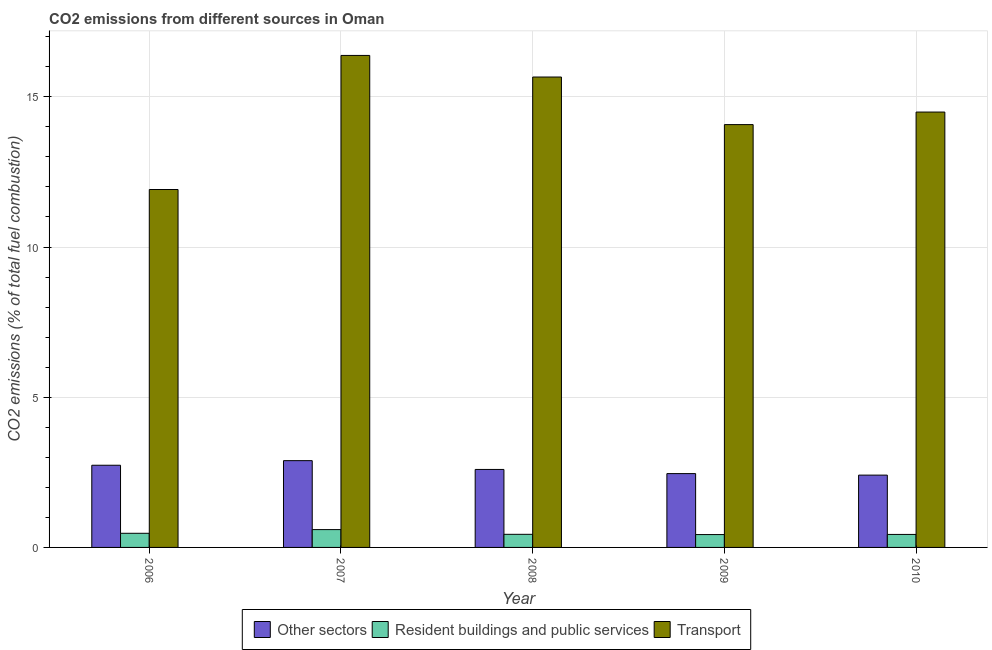How many bars are there on the 4th tick from the left?
Keep it short and to the point. 3. What is the label of the 5th group of bars from the left?
Your answer should be very brief. 2010. In how many cases, is the number of bars for a given year not equal to the number of legend labels?
Your answer should be compact. 0. What is the percentage of co2 emissions from resident buildings and public services in 2008?
Provide a short and direct response. 0.44. Across all years, what is the maximum percentage of co2 emissions from resident buildings and public services?
Ensure brevity in your answer.  0.59. Across all years, what is the minimum percentage of co2 emissions from transport?
Offer a terse response. 11.92. In which year was the percentage of co2 emissions from resident buildings and public services maximum?
Offer a terse response. 2007. What is the total percentage of co2 emissions from other sectors in the graph?
Offer a terse response. 13.09. What is the difference between the percentage of co2 emissions from transport in 2009 and that in 2010?
Keep it short and to the point. -0.42. What is the difference between the percentage of co2 emissions from resident buildings and public services in 2010 and the percentage of co2 emissions from transport in 2006?
Your answer should be compact. -0.04. What is the average percentage of co2 emissions from transport per year?
Ensure brevity in your answer.  14.5. In the year 2007, what is the difference between the percentage of co2 emissions from resident buildings and public services and percentage of co2 emissions from transport?
Provide a succinct answer. 0. In how many years, is the percentage of co2 emissions from resident buildings and public services greater than 12 %?
Provide a short and direct response. 0. What is the ratio of the percentage of co2 emissions from resident buildings and public services in 2007 to that in 2008?
Your response must be concise. 1.36. What is the difference between the highest and the second highest percentage of co2 emissions from other sectors?
Your answer should be very brief. 0.15. What is the difference between the highest and the lowest percentage of co2 emissions from other sectors?
Make the answer very short. 0.48. Is the sum of the percentage of co2 emissions from other sectors in 2006 and 2007 greater than the maximum percentage of co2 emissions from resident buildings and public services across all years?
Offer a very short reply. Yes. What does the 2nd bar from the left in 2007 represents?
Your answer should be compact. Resident buildings and public services. What does the 1st bar from the right in 2007 represents?
Your answer should be very brief. Transport. Is it the case that in every year, the sum of the percentage of co2 emissions from other sectors and percentage of co2 emissions from resident buildings and public services is greater than the percentage of co2 emissions from transport?
Your answer should be very brief. No. How many bars are there?
Your response must be concise. 15. Are the values on the major ticks of Y-axis written in scientific E-notation?
Provide a short and direct response. No. Does the graph contain any zero values?
Provide a succinct answer. No. Does the graph contain grids?
Make the answer very short. Yes. Where does the legend appear in the graph?
Your answer should be compact. Bottom center. How many legend labels are there?
Ensure brevity in your answer.  3. What is the title of the graph?
Keep it short and to the point. CO2 emissions from different sources in Oman. What is the label or title of the X-axis?
Provide a succinct answer. Year. What is the label or title of the Y-axis?
Give a very brief answer. CO2 emissions (% of total fuel combustion). What is the CO2 emissions (% of total fuel combustion) in Other sectors in 2006?
Keep it short and to the point. 2.74. What is the CO2 emissions (% of total fuel combustion) of Resident buildings and public services in 2006?
Your answer should be very brief. 0.47. What is the CO2 emissions (% of total fuel combustion) in Transport in 2006?
Make the answer very short. 11.92. What is the CO2 emissions (% of total fuel combustion) in Other sectors in 2007?
Offer a terse response. 2.89. What is the CO2 emissions (% of total fuel combustion) in Resident buildings and public services in 2007?
Your answer should be very brief. 0.59. What is the CO2 emissions (% of total fuel combustion) of Transport in 2007?
Ensure brevity in your answer.  16.38. What is the CO2 emissions (% of total fuel combustion) in Other sectors in 2008?
Keep it short and to the point. 2.6. What is the CO2 emissions (% of total fuel combustion) in Resident buildings and public services in 2008?
Offer a terse response. 0.44. What is the CO2 emissions (% of total fuel combustion) in Transport in 2008?
Make the answer very short. 15.66. What is the CO2 emissions (% of total fuel combustion) of Other sectors in 2009?
Make the answer very short. 2.46. What is the CO2 emissions (% of total fuel combustion) in Resident buildings and public services in 2009?
Ensure brevity in your answer.  0.43. What is the CO2 emissions (% of total fuel combustion) of Transport in 2009?
Your response must be concise. 14.08. What is the CO2 emissions (% of total fuel combustion) in Other sectors in 2010?
Make the answer very short. 2.41. What is the CO2 emissions (% of total fuel combustion) in Resident buildings and public services in 2010?
Provide a short and direct response. 0.43. What is the CO2 emissions (% of total fuel combustion) of Transport in 2010?
Your answer should be very brief. 14.49. Across all years, what is the maximum CO2 emissions (% of total fuel combustion) in Other sectors?
Your answer should be very brief. 2.89. Across all years, what is the maximum CO2 emissions (% of total fuel combustion) in Resident buildings and public services?
Offer a very short reply. 0.59. Across all years, what is the maximum CO2 emissions (% of total fuel combustion) of Transport?
Your response must be concise. 16.38. Across all years, what is the minimum CO2 emissions (% of total fuel combustion) of Other sectors?
Offer a very short reply. 2.41. Across all years, what is the minimum CO2 emissions (% of total fuel combustion) of Resident buildings and public services?
Offer a terse response. 0.43. Across all years, what is the minimum CO2 emissions (% of total fuel combustion) in Transport?
Your response must be concise. 11.92. What is the total CO2 emissions (% of total fuel combustion) of Other sectors in the graph?
Your answer should be very brief. 13.09. What is the total CO2 emissions (% of total fuel combustion) in Resident buildings and public services in the graph?
Give a very brief answer. 2.36. What is the total CO2 emissions (% of total fuel combustion) in Transport in the graph?
Your answer should be compact. 72.52. What is the difference between the CO2 emissions (% of total fuel combustion) in Other sectors in 2006 and that in 2007?
Provide a succinct answer. -0.15. What is the difference between the CO2 emissions (% of total fuel combustion) of Resident buildings and public services in 2006 and that in 2007?
Ensure brevity in your answer.  -0.12. What is the difference between the CO2 emissions (% of total fuel combustion) of Transport in 2006 and that in 2007?
Provide a succinct answer. -4.46. What is the difference between the CO2 emissions (% of total fuel combustion) in Other sectors in 2006 and that in 2008?
Offer a very short reply. 0.14. What is the difference between the CO2 emissions (% of total fuel combustion) of Resident buildings and public services in 2006 and that in 2008?
Make the answer very short. 0.03. What is the difference between the CO2 emissions (% of total fuel combustion) of Transport in 2006 and that in 2008?
Give a very brief answer. -3.74. What is the difference between the CO2 emissions (% of total fuel combustion) in Other sectors in 2006 and that in 2009?
Provide a short and direct response. 0.28. What is the difference between the CO2 emissions (% of total fuel combustion) in Resident buildings and public services in 2006 and that in 2009?
Give a very brief answer. 0.04. What is the difference between the CO2 emissions (% of total fuel combustion) in Transport in 2006 and that in 2009?
Keep it short and to the point. -2.16. What is the difference between the CO2 emissions (% of total fuel combustion) of Other sectors in 2006 and that in 2010?
Provide a short and direct response. 0.33. What is the difference between the CO2 emissions (% of total fuel combustion) of Resident buildings and public services in 2006 and that in 2010?
Provide a succinct answer. 0.04. What is the difference between the CO2 emissions (% of total fuel combustion) in Transport in 2006 and that in 2010?
Keep it short and to the point. -2.58. What is the difference between the CO2 emissions (% of total fuel combustion) of Other sectors in 2007 and that in 2008?
Give a very brief answer. 0.29. What is the difference between the CO2 emissions (% of total fuel combustion) of Resident buildings and public services in 2007 and that in 2008?
Make the answer very short. 0.16. What is the difference between the CO2 emissions (% of total fuel combustion) in Transport in 2007 and that in 2008?
Your answer should be compact. 0.72. What is the difference between the CO2 emissions (% of total fuel combustion) in Other sectors in 2007 and that in 2009?
Provide a succinct answer. 0.43. What is the difference between the CO2 emissions (% of total fuel combustion) in Resident buildings and public services in 2007 and that in 2009?
Offer a terse response. 0.17. What is the difference between the CO2 emissions (% of total fuel combustion) of Transport in 2007 and that in 2009?
Your answer should be compact. 2.3. What is the difference between the CO2 emissions (% of total fuel combustion) in Other sectors in 2007 and that in 2010?
Your response must be concise. 0.48. What is the difference between the CO2 emissions (% of total fuel combustion) in Resident buildings and public services in 2007 and that in 2010?
Make the answer very short. 0.16. What is the difference between the CO2 emissions (% of total fuel combustion) in Transport in 2007 and that in 2010?
Your answer should be compact. 1.89. What is the difference between the CO2 emissions (% of total fuel combustion) in Other sectors in 2008 and that in 2009?
Make the answer very short. 0.14. What is the difference between the CO2 emissions (% of total fuel combustion) in Resident buildings and public services in 2008 and that in 2009?
Your answer should be very brief. 0.01. What is the difference between the CO2 emissions (% of total fuel combustion) of Transport in 2008 and that in 2009?
Ensure brevity in your answer.  1.58. What is the difference between the CO2 emissions (% of total fuel combustion) of Other sectors in 2008 and that in 2010?
Your answer should be compact. 0.19. What is the difference between the CO2 emissions (% of total fuel combustion) in Resident buildings and public services in 2008 and that in 2010?
Provide a succinct answer. 0. What is the difference between the CO2 emissions (% of total fuel combustion) of Transport in 2008 and that in 2010?
Provide a succinct answer. 1.17. What is the difference between the CO2 emissions (% of total fuel combustion) of Other sectors in 2009 and that in 2010?
Your answer should be very brief. 0.05. What is the difference between the CO2 emissions (% of total fuel combustion) of Resident buildings and public services in 2009 and that in 2010?
Offer a very short reply. -0. What is the difference between the CO2 emissions (% of total fuel combustion) in Transport in 2009 and that in 2010?
Your answer should be compact. -0.42. What is the difference between the CO2 emissions (% of total fuel combustion) of Other sectors in 2006 and the CO2 emissions (% of total fuel combustion) of Resident buildings and public services in 2007?
Ensure brevity in your answer.  2.14. What is the difference between the CO2 emissions (% of total fuel combustion) in Other sectors in 2006 and the CO2 emissions (% of total fuel combustion) in Transport in 2007?
Your answer should be compact. -13.64. What is the difference between the CO2 emissions (% of total fuel combustion) in Resident buildings and public services in 2006 and the CO2 emissions (% of total fuel combustion) in Transport in 2007?
Your answer should be very brief. -15.91. What is the difference between the CO2 emissions (% of total fuel combustion) in Other sectors in 2006 and the CO2 emissions (% of total fuel combustion) in Transport in 2008?
Ensure brevity in your answer.  -12.92. What is the difference between the CO2 emissions (% of total fuel combustion) in Resident buildings and public services in 2006 and the CO2 emissions (% of total fuel combustion) in Transport in 2008?
Make the answer very short. -15.19. What is the difference between the CO2 emissions (% of total fuel combustion) in Other sectors in 2006 and the CO2 emissions (% of total fuel combustion) in Resident buildings and public services in 2009?
Provide a succinct answer. 2.31. What is the difference between the CO2 emissions (% of total fuel combustion) in Other sectors in 2006 and the CO2 emissions (% of total fuel combustion) in Transport in 2009?
Your response must be concise. -11.34. What is the difference between the CO2 emissions (% of total fuel combustion) of Resident buildings and public services in 2006 and the CO2 emissions (% of total fuel combustion) of Transport in 2009?
Provide a succinct answer. -13.6. What is the difference between the CO2 emissions (% of total fuel combustion) of Other sectors in 2006 and the CO2 emissions (% of total fuel combustion) of Resident buildings and public services in 2010?
Your response must be concise. 2.3. What is the difference between the CO2 emissions (% of total fuel combustion) in Other sectors in 2006 and the CO2 emissions (% of total fuel combustion) in Transport in 2010?
Make the answer very short. -11.76. What is the difference between the CO2 emissions (% of total fuel combustion) in Resident buildings and public services in 2006 and the CO2 emissions (% of total fuel combustion) in Transport in 2010?
Make the answer very short. -14.02. What is the difference between the CO2 emissions (% of total fuel combustion) in Other sectors in 2007 and the CO2 emissions (% of total fuel combustion) in Resident buildings and public services in 2008?
Keep it short and to the point. 2.45. What is the difference between the CO2 emissions (% of total fuel combustion) of Other sectors in 2007 and the CO2 emissions (% of total fuel combustion) of Transport in 2008?
Your answer should be compact. -12.77. What is the difference between the CO2 emissions (% of total fuel combustion) of Resident buildings and public services in 2007 and the CO2 emissions (% of total fuel combustion) of Transport in 2008?
Your answer should be compact. -15.07. What is the difference between the CO2 emissions (% of total fuel combustion) in Other sectors in 2007 and the CO2 emissions (% of total fuel combustion) in Resident buildings and public services in 2009?
Provide a short and direct response. 2.46. What is the difference between the CO2 emissions (% of total fuel combustion) of Other sectors in 2007 and the CO2 emissions (% of total fuel combustion) of Transport in 2009?
Give a very brief answer. -11.19. What is the difference between the CO2 emissions (% of total fuel combustion) of Resident buildings and public services in 2007 and the CO2 emissions (% of total fuel combustion) of Transport in 2009?
Provide a short and direct response. -13.48. What is the difference between the CO2 emissions (% of total fuel combustion) in Other sectors in 2007 and the CO2 emissions (% of total fuel combustion) in Resident buildings and public services in 2010?
Make the answer very short. 2.46. What is the difference between the CO2 emissions (% of total fuel combustion) of Other sectors in 2007 and the CO2 emissions (% of total fuel combustion) of Transport in 2010?
Your response must be concise. -11.6. What is the difference between the CO2 emissions (% of total fuel combustion) in Resident buildings and public services in 2007 and the CO2 emissions (% of total fuel combustion) in Transport in 2010?
Give a very brief answer. -13.9. What is the difference between the CO2 emissions (% of total fuel combustion) of Other sectors in 2008 and the CO2 emissions (% of total fuel combustion) of Resident buildings and public services in 2009?
Offer a very short reply. 2.17. What is the difference between the CO2 emissions (% of total fuel combustion) in Other sectors in 2008 and the CO2 emissions (% of total fuel combustion) in Transport in 2009?
Offer a very short reply. -11.48. What is the difference between the CO2 emissions (% of total fuel combustion) of Resident buildings and public services in 2008 and the CO2 emissions (% of total fuel combustion) of Transport in 2009?
Make the answer very short. -13.64. What is the difference between the CO2 emissions (% of total fuel combustion) of Other sectors in 2008 and the CO2 emissions (% of total fuel combustion) of Resident buildings and public services in 2010?
Offer a terse response. 2.16. What is the difference between the CO2 emissions (% of total fuel combustion) in Other sectors in 2008 and the CO2 emissions (% of total fuel combustion) in Transport in 2010?
Your answer should be very brief. -11.9. What is the difference between the CO2 emissions (% of total fuel combustion) of Resident buildings and public services in 2008 and the CO2 emissions (% of total fuel combustion) of Transport in 2010?
Offer a very short reply. -14.06. What is the difference between the CO2 emissions (% of total fuel combustion) in Other sectors in 2009 and the CO2 emissions (% of total fuel combustion) in Resident buildings and public services in 2010?
Offer a very short reply. 2.02. What is the difference between the CO2 emissions (% of total fuel combustion) of Other sectors in 2009 and the CO2 emissions (% of total fuel combustion) of Transport in 2010?
Your answer should be very brief. -12.04. What is the difference between the CO2 emissions (% of total fuel combustion) in Resident buildings and public services in 2009 and the CO2 emissions (% of total fuel combustion) in Transport in 2010?
Your answer should be compact. -14.07. What is the average CO2 emissions (% of total fuel combustion) of Other sectors per year?
Your answer should be compact. 2.62. What is the average CO2 emissions (% of total fuel combustion) of Resident buildings and public services per year?
Make the answer very short. 0.47. What is the average CO2 emissions (% of total fuel combustion) in Transport per year?
Ensure brevity in your answer.  14.5. In the year 2006, what is the difference between the CO2 emissions (% of total fuel combustion) of Other sectors and CO2 emissions (% of total fuel combustion) of Resident buildings and public services?
Offer a very short reply. 2.27. In the year 2006, what is the difference between the CO2 emissions (% of total fuel combustion) in Other sectors and CO2 emissions (% of total fuel combustion) in Transport?
Your answer should be very brief. -9.18. In the year 2006, what is the difference between the CO2 emissions (% of total fuel combustion) of Resident buildings and public services and CO2 emissions (% of total fuel combustion) of Transport?
Your response must be concise. -11.44. In the year 2007, what is the difference between the CO2 emissions (% of total fuel combustion) in Other sectors and CO2 emissions (% of total fuel combustion) in Resident buildings and public services?
Offer a terse response. 2.3. In the year 2007, what is the difference between the CO2 emissions (% of total fuel combustion) in Other sectors and CO2 emissions (% of total fuel combustion) in Transport?
Offer a very short reply. -13.49. In the year 2007, what is the difference between the CO2 emissions (% of total fuel combustion) in Resident buildings and public services and CO2 emissions (% of total fuel combustion) in Transport?
Provide a succinct answer. -15.79. In the year 2008, what is the difference between the CO2 emissions (% of total fuel combustion) in Other sectors and CO2 emissions (% of total fuel combustion) in Resident buildings and public services?
Offer a terse response. 2.16. In the year 2008, what is the difference between the CO2 emissions (% of total fuel combustion) in Other sectors and CO2 emissions (% of total fuel combustion) in Transport?
Make the answer very short. -13.06. In the year 2008, what is the difference between the CO2 emissions (% of total fuel combustion) of Resident buildings and public services and CO2 emissions (% of total fuel combustion) of Transport?
Your answer should be very brief. -15.22. In the year 2009, what is the difference between the CO2 emissions (% of total fuel combustion) in Other sectors and CO2 emissions (% of total fuel combustion) in Resident buildings and public services?
Keep it short and to the point. 2.03. In the year 2009, what is the difference between the CO2 emissions (% of total fuel combustion) in Other sectors and CO2 emissions (% of total fuel combustion) in Transport?
Give a very brief answer. -11.62. In the year 2009, what is the difference between the CO2 emissions (% of total fuel combustion) of Resident buildings and public services and CO2 emissions (% of total fuel combustion) of Transport?
Your response must be concise. -13.65. In the year 2010, what is the difference between the CO2 emissions (% of total fuel combustion) of Other sectors and CO2 emissions (% of total fuel combustion) of Resident buildings and public services?
Provide a short and direct response. 1.97. In the year 2010, what is the difference between the CO2 emissions (% of total fuel combustion) of Other sectors and CO2 emissions (% of total fuel combustion) of Transport?
Keep it short and to the point. -12.09. In the year 2010, what is the difference between the CO2 emissions (% of total fuel combustion) of Resident buildings and public services and CO2 emissions (% of total fuel combustion) of Transport?
Make the answer very short. -14.06. What is the ratio of the CO2 emissions (% of total fuel combustion) in Other sectors in 2006 to that in 2007?
Make the answer very short. 0.95. What is the ratio of the CO2 emissions (% of total fuel combustion) of Resident buildings and public services in 2006 to that in 2007?
Your response must be concise. 0.79. What is the ratio of the CO2 emissions (% of total fuel combustion) in Transport in 2006 to that in 2007?
Give a very brief answer. 0.73. What is the ratio of the CO2 emissions (% of total fuel combustion) of Other sectors in 2006 to that in 2008?
Provide a short and direct response. 1.05. What is the ratio of the CO2 emissions (% of total fuel combustion) in Resident buildings and public services in 2006 to that in 2008?
Offer a very short reply. 1.08. What is the ratio of the CO2 emissions (% of total fuel combustion) of Transport in 2006 to that in 2008?
Provide a succinct answer. 0.76. What is the ratio of the CO2 emissions (% of total fuel combustion) of Other sectors in 2006 to that in 2009?
Offer a very short reply. 1.11. What is the ratio of the CO2 emissions (% of total fuel combustion) of Resident buildings and public services in 2006 to that in 2009?
Your answer should be compact. 1.1. What is the ratio of the CO2 emissions (% of total fuel combustion) of Transport in 2006 to that in 2009?
Provide a short and direct response. 0.85. What is the ratio of the CO2 emissions (% of total fuel combustion) of Other sectors in 2006 to that in 2010?
Offer a terse response. 1.14. What is the ratio of the CO2 emissions (% of total fuel combustion) of Resident buildings and public services in 2006 to that in 2010?
Make the answer very short. 1.09. What is the ratio of the CO2 emissions (% of total fuel combustion) of Transport in 2006 to that in 2010?
Keep it short and to the point. 0.82. What is the ratio of the CO2 emissions (% of total fuel combustion) in Other sectors in 2007 to that in 2008?
Provide a short and direct response. 1.11. What is the ratio of the CO2 emissions (% of total fuel combustion) in Resident buildings and public services in 2007 to that in 2008?
Provide a succinct answer. 1.36. What is the ratio of the CO2 emissions (% of total fuel combustion) of Transport in 2007 to that in 2008?
Provide a short and direct response. 1.05. What is the ratio of the CO2 emissions (% of total fuel combustion) in Other sectors in 2007 to that in 2009?
Offer a very short reply. 1.18. What is the ratio of the CO2 emissions (% of total fuel combustion) of Resident buildings and public services in 2007 to that in 2009?
Offer a very short reply. 1.39. What is the ratio of the CO2 emissions (% of total fuel combustion) of Transport in 2007 to that in 2009?
Provide a succinct answer. 1.16. What is the ratio of the CO2 emissions (% of total fuel combustion) in Other sectors in 2007 to that in 2010?
Your answer should be very brief. 1.2. What is the ratio of the CO2 emissions (% of total fuel combustion) of Resident buildings and public services in 2007 to that in 2010?
Your answer should be very brief. 1.37. What is the ratio of the CO2 emissions (% of total fuel combustion) in Transport in 2007 to that in 2010?
Make the answer very short. 1.13. What is the ratio of the CO2 emissions (% of total fuel combustion) of Other sectors in 2008 to that in 2009?
Ensure brevity in your answer.  1.06. What is the ratio of the CO2 emissions (% of total fuel combustion) in Resident buildings and public services in 2008 to that in 2009?
Offer a very short reply. 1.02. What is the ratio of the CO2 emissions (% of total fuel combustion) of Transport in 2008 to that in 2009?
Your answer should be very brief. 1.11. What is the ratio of the CO2 emissions (% of total fuel combustion) in Other sectors in 2008 to that in 2010?
Your answer should be compact. 1.08. What is the ratio of the CO2 emissions (% of total fuel combustion) in Resident buildings and public services in 2008 to that in 2010?
Offer a terse response. 1.01. What is the ratio of the CO2 emissions (% of total fuel combustion) of Transport in 2008 to that in 2010?
Keep it short and to the point. 1.08. What is the ratio of the CO2 emissions (% of total fuel combustion) in Other sectors in 2009 to that in 2010?
Make the answer very short. 1.02. What is the ratio of the CO2 emissions (% of total fuel combustion) of Transport in 2009 to that in 2010?
Your answer should be compact. 0.97. What is the difference between the highest and the second highest CO2 emissions (% of total fuel combustion) in Other sectors?
Ensure brevity in your answer.  0.15. What is the difference between the highest and the second highest CO2 emissions (% of total fuel combustion) of Resident buildings and public services?
Your answer should be very brief. 0.12. What is the difference between the highest and the second highest CO2 emissions (% of total fuel combustion) in Transport?
Keep it short and to the point. 0.72. What is the difference between the highest and the lowest CO2 emissions (% of total fuel combustion) of Other sectors?
Provide a short and direct response. 0.48. What is the difference between the highest and the lowest CO2 emissions (% of total fuel combustion) of Resident buildings and public services?
Give a very brief answer. 0.17. What is the difference between the highest and the lowest CO2 emissions (% of total fuel combustion) of Transport?
Keep it short and to the point. 4.46. 